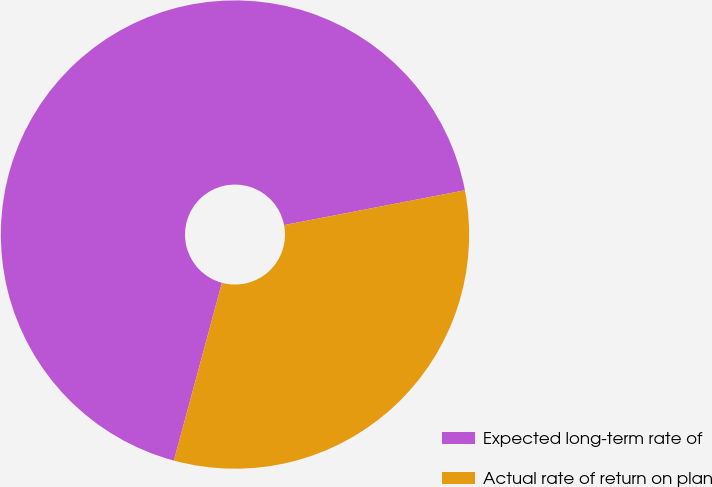Convert chart. <chart><loc_0><loc_0><loc_500><loc_500><pie_chart><fcel>Expected long-term rate of<fcel>Actual rate of return on plan<nl><fcel>67.77%<fcel>32.23%<nl></chart> 